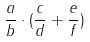<formula> <loc_0><loc_0><loc_500><loc_500>\frac { a } { b } \cdot ( \frac { c } { d } + \frac { e } { f } )</formula> 